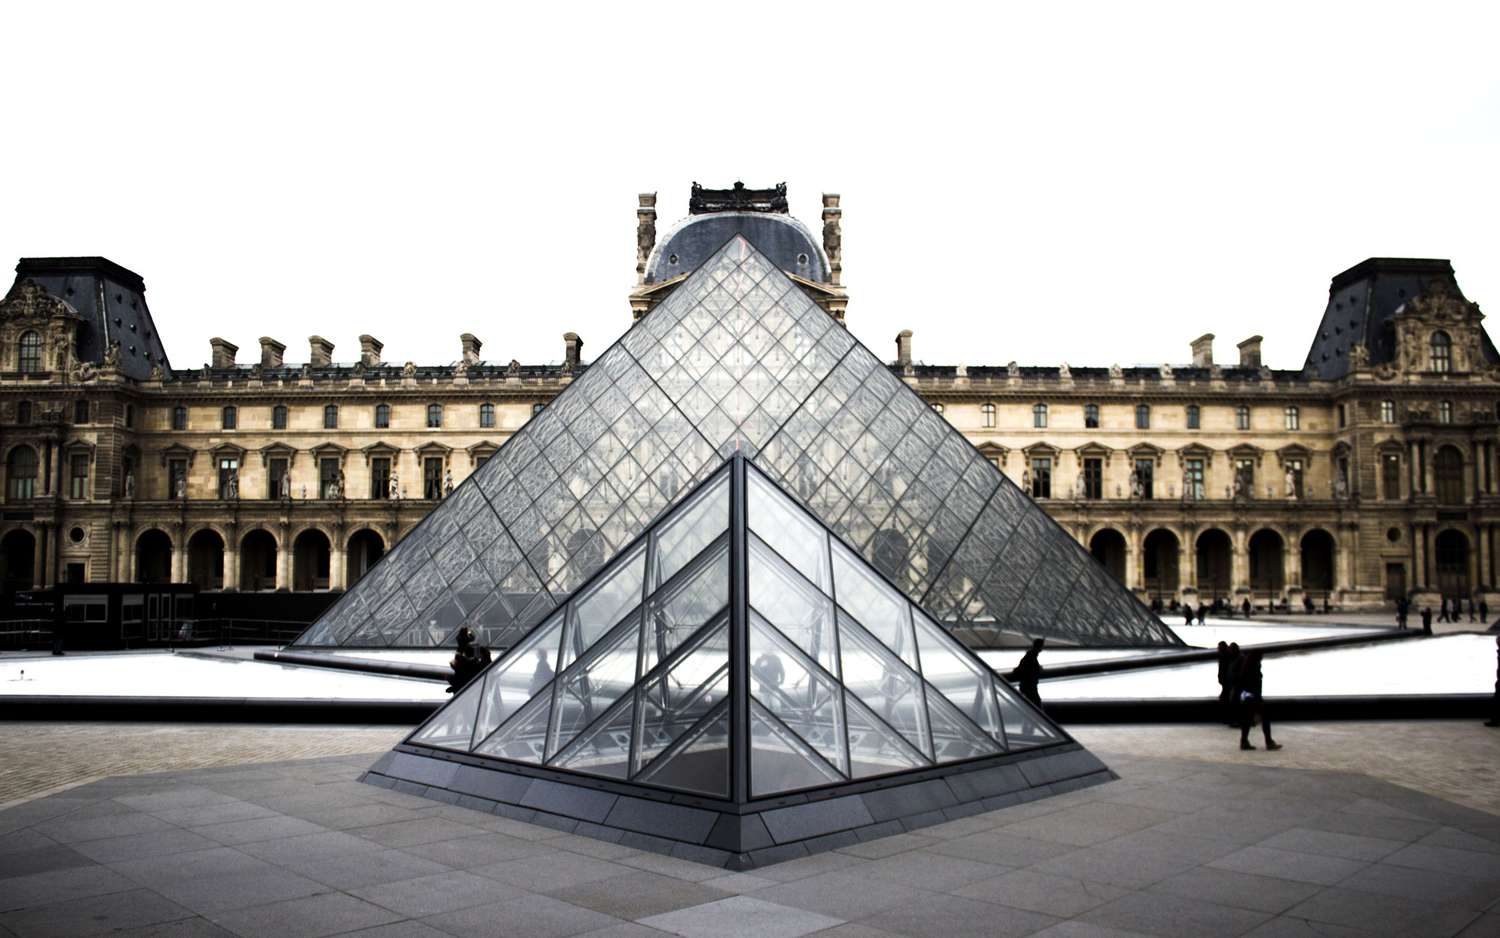Imagine if the Louvre pyramid could emit light. How would it alter the evening experience for visitors? If the Louvre pyramid could emit light, the evening experience for visitors would be transformed into a magical and enchanting spectacle. The pyramid would become a beacon of radiance in the heart of Paris, illuminating the courtyard and highlighting the magnificent architecture of the palace with a soft, mesmerizing glow. This lighting effect would enhance the pyramid’s modern elegance, casting dramatic shadows and reflections that would dance across the historic stones, creating an otherworldly ambiance. Imagine the glass surfaces shimmering like a diamond, throwing prismatic hues into the night and turning the museum grounds into a dreamscape where history meets futuristic vision. Visitors would be captivated by the interplay of light and structure, experiencing the Louvre in an entirely new and awe-inspiring way. Describe a detailed scenario of a visitor's experience at the Louvre during sunset. As the sun begins to set over Paris, a visitor approaches the Louvre Museum, eager to see the famous pyramid as the daylight fades. The sky is painted in strokes of orange, pink, and purple, casting a warm glow that bathes the entire complex in a romantic light. Walking towards the glass pyramid, the visitor notices how the reflective surfaces catch the dying light, transforming the structure into a colossal jewel. The tranquil pool surrounding the pyramid mirrors the sky’s changing colors, creating a perfect harmony between nature and man-made artistry. 

As the visitor steps closer, they hear the gentle hum of conversations, the soft murmurs of history enthusiasts discussing art intermingled with the excited chatter of tourists. The grandeur of the Louvre Palace looms majestically behind the pyramid, its classical architecture forming a picturesque backdrop that seems almost surreal in the dimming light.

Taking a seat by the pool, the visitor allows themselves a moment of quiet reflection, absorbing the splendor around them. The water's surface now reflects the first stars appearing in the twilight sky, with the glass panes of the pyramid gleaming softly. It’s a peaceful, almost meditative moment, a perfect end to a day exploring the corridors of one of the world's greatest repositories of art and history. As the lights of the city start to twinkle, the visitor feels a deep connection to this timeless place, where every stone and every glass panel tells a story of human achievement and creativity. 